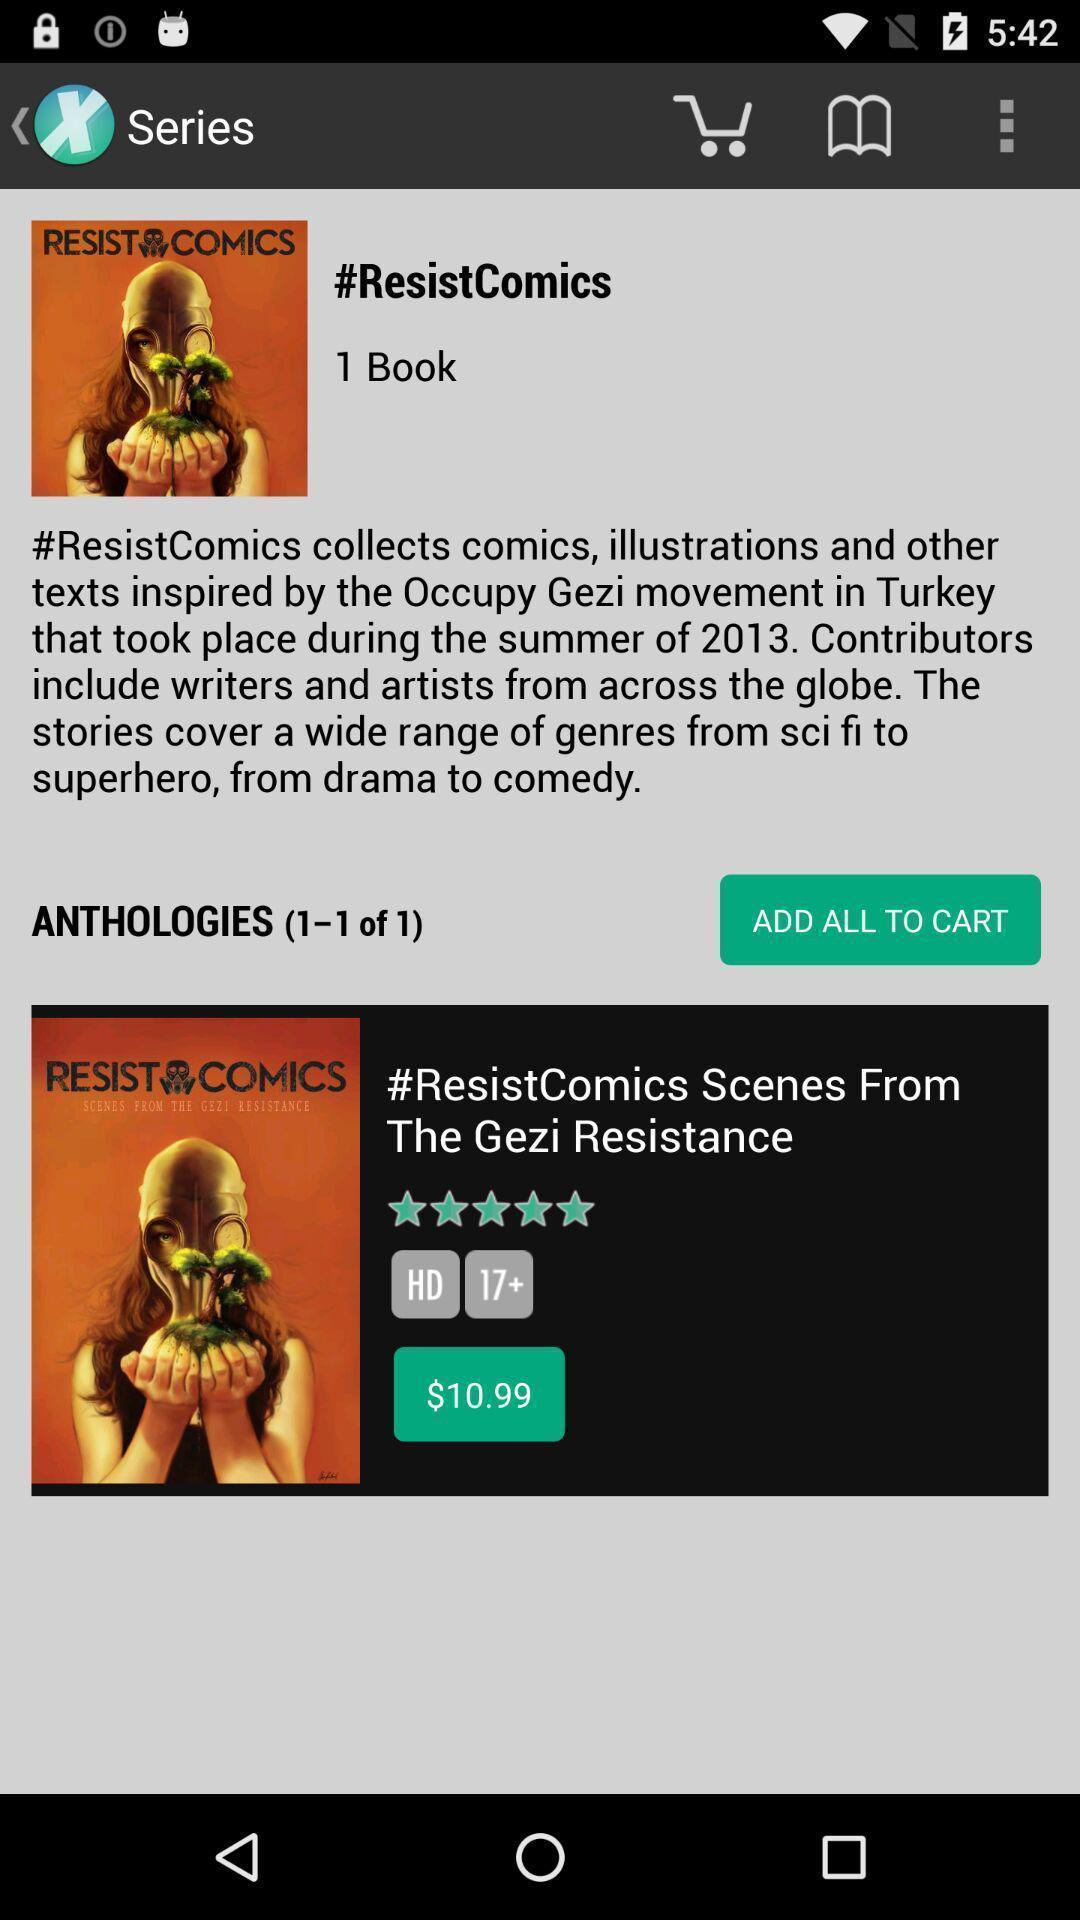Describe this image in words. Screen shows series. 